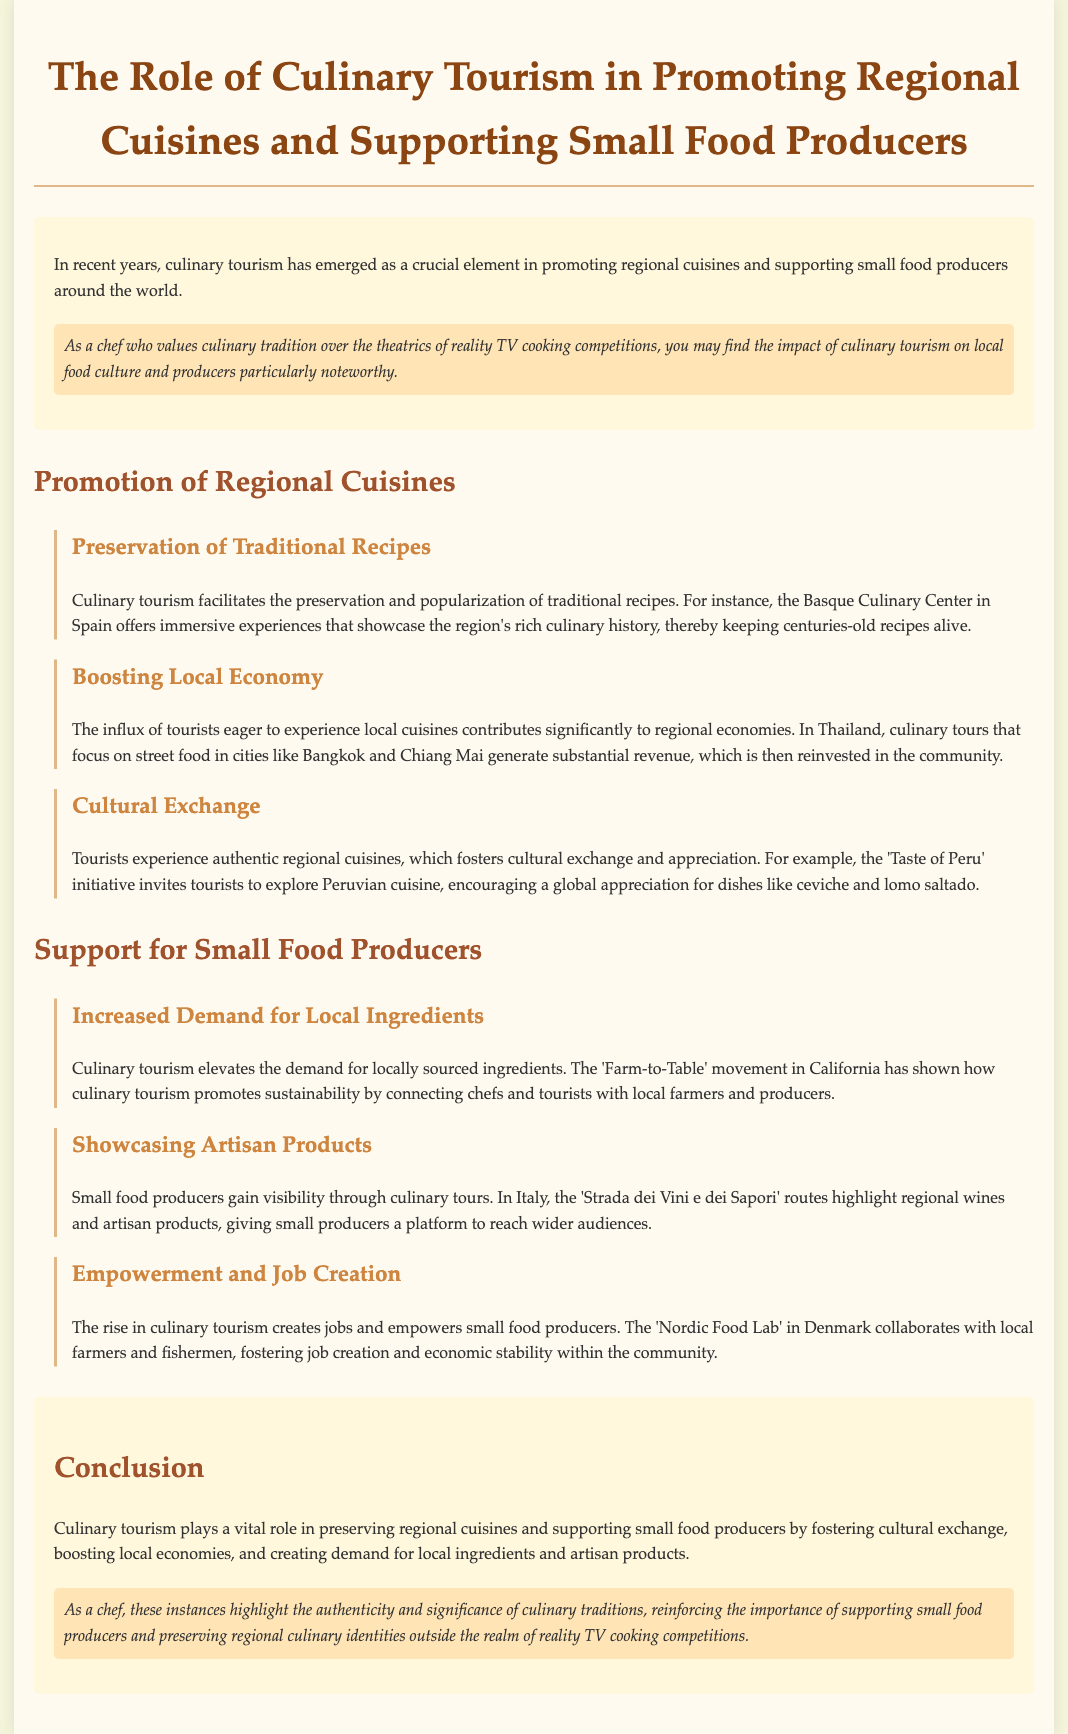what is the title of the case study? The title is explicitly mentioned at the beginning of the document, which describes its focus on culinary tourism.
Answer: The Role of Culinary Tourism in Promoting Regional Cuisines and Supporting Small Food Producers what culinary center is mentioned in Spain? The document specifically references the Basque Culinary Center as an example of promoting traditional recipes.
Answer: Basque Culinary Center which movement in California is mentioned? The 'Farm-to-Table' movement is highlighted in the document regarding its impact on local sourcing and sustainability.
Answer: Farm-to-Table what is one benefit of culinary tourism for local economies? The document states that culinary tourism contributes significantly to regional economies through tourist spending.
Answer: Boosting local economy which initiative invites tourists to explore Peruvian cuisine? The document names an initiative designed to foster cultural exchange by showcasing regional dishes in Peru.
Answer: Taste of Peru how does culinary tourism empower small food producers? The document highlights job creation and economic stability as key benefits for small producers in the context of culinary tourism.
Answer: Empowerment and job creation what is a key role of culinary tourism according to the conclusion? The conclusion emphasizes the preservation of regional cuisines as a vital aspect of what culinary tourism achieves.
Answer: Preserving regional cuisines which country is associated with 'Strada dei Vini e dei Sapori'? The document mentions Italy specifically in relation to highlighting regional wines and artisan products.
Answer: Italy 